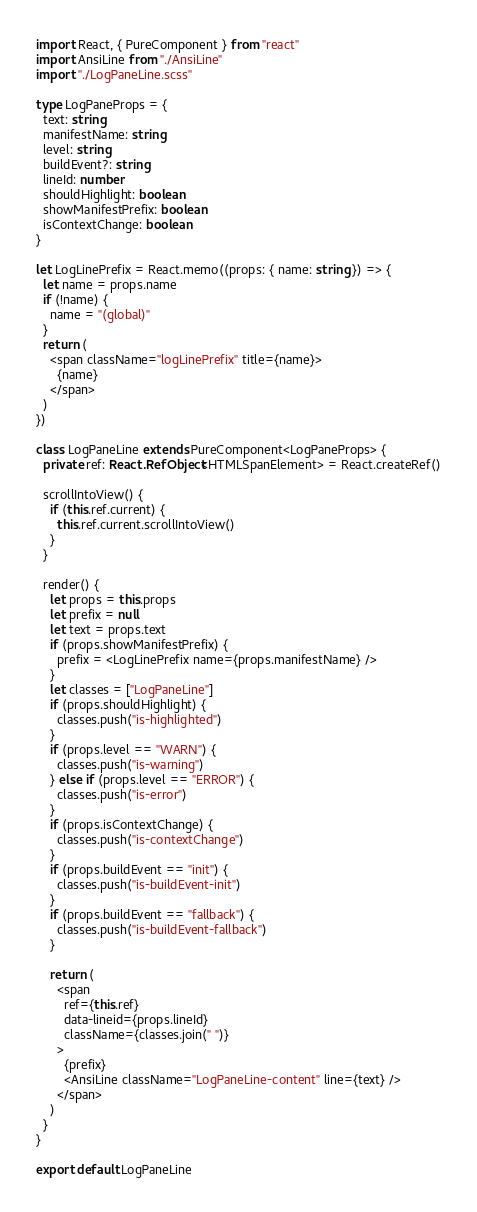<code> <loc_0><loc_0><loc_500><loc_500><_TypeScript_>import React, { PureComponent } from "react"
import AnsiLine from "./AnsiLine"
import "./LogPaneLine.scss"

type LogPaneProps = {
  text: string
  manifestName: string
  level: string
  buildEvent?: string
  lineId: number
  shouldHighlight: boolean
  showManifestPrefix: boolean
  isContextChange: boolean
}

let LogLinePrefix = React.memo((props: { name: string }) => {
  let name = props.name
  if (!name) {
    name = "(global)"
  }
  return (
    <span className="logLinePrefix" title={name}>
      {name}
    </span>
  )
})

class LogPaneLine extends PureComponent<LogPaneProps> {
  private ref: React.RefObject<HTMLSpanElement> = React.createRef()

  scrollIntoView() {
    if (this.ref.current) {
      this.ref.current.scrollIntoView()
    }
  }

  render() {
    let props = this.props
    let prefix = null
    let text = props.text
    if (props.showManifestPrefix) {
      prefix = <LogLinePrefix name={props.manifestName} />
    }
    let classes = ["LogPaneLine"]
    if (props.shouldHighlight) {
      classes.push("is-highlighted")
    }
    if (props.level == "WARN") {
      classes.push("is-warning")
    } else if (props.level == "ERROR") {
      classes.push("is-error")
    }
    if (props.isContextChange) {
      classes.push("is-contextChange")
    }
    if (props.buildEvent == "init") {
      classes.push("is-buildEvent-init")
    }
    if (props.buildEvent == "fallback") {
      classes.push("is-buildEvent-fallback")
    }

    return (
      <span
        ref={this.ref}
        data-lineid={props.lineId}
        className={classes.join(" ")}
      >
        {prefix}
        <AnsiLine className="LogPaneLine-content" line={text} />
      </span>
    )
  }
}

export default LogPaneLine
</code> 